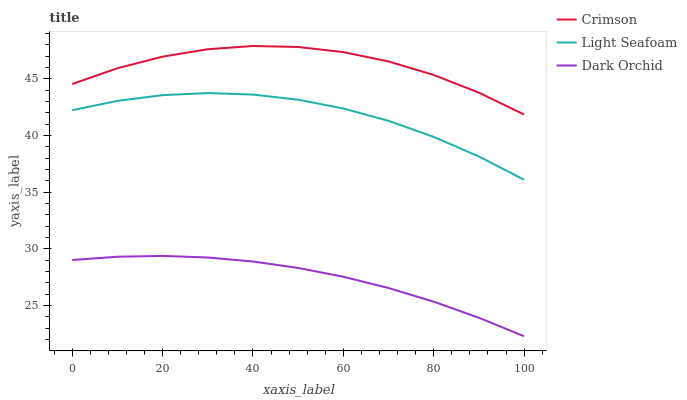Does Dark Orchid have the minimum area under the curve?
Answer yes or no. Yes. Does Crimson have the maximum area under the curve?
Answer yes or no. Yes. Does Light Seafoam have the minimum area under the curve?
Answer yes or no. No. Does Light Seafoam have the maximum area under the curve?
Answer yes or no. No. Is Dark Orchid the smoothest?
Answer yes or no. Yes. Is Crimson the roughest?
Answer yes or no. Yes. Is Light Seafoam the smoothest?
Answer yes or no. No. Is Light Seafoam the roughest?
Answer yes or no. No. Does Dark Orchid have the lowest value?
Answer yes or no. Yes. Does Light Seafoam have the lowest value?
Answer yes or no. No. Does Crimson have the highest value?
Answer yes or no. Yes. Does Light Seafoam have the highest value?
Answer yes or no. No. Is Dark Orchid less than Crimson?
Answer yes or no. Yes. Is Light Seafoam greater than Dark Orchid?
Answer yes or no. Yes. Does Dark Orchid intersect Crimson?
Answer yes or no. No. 